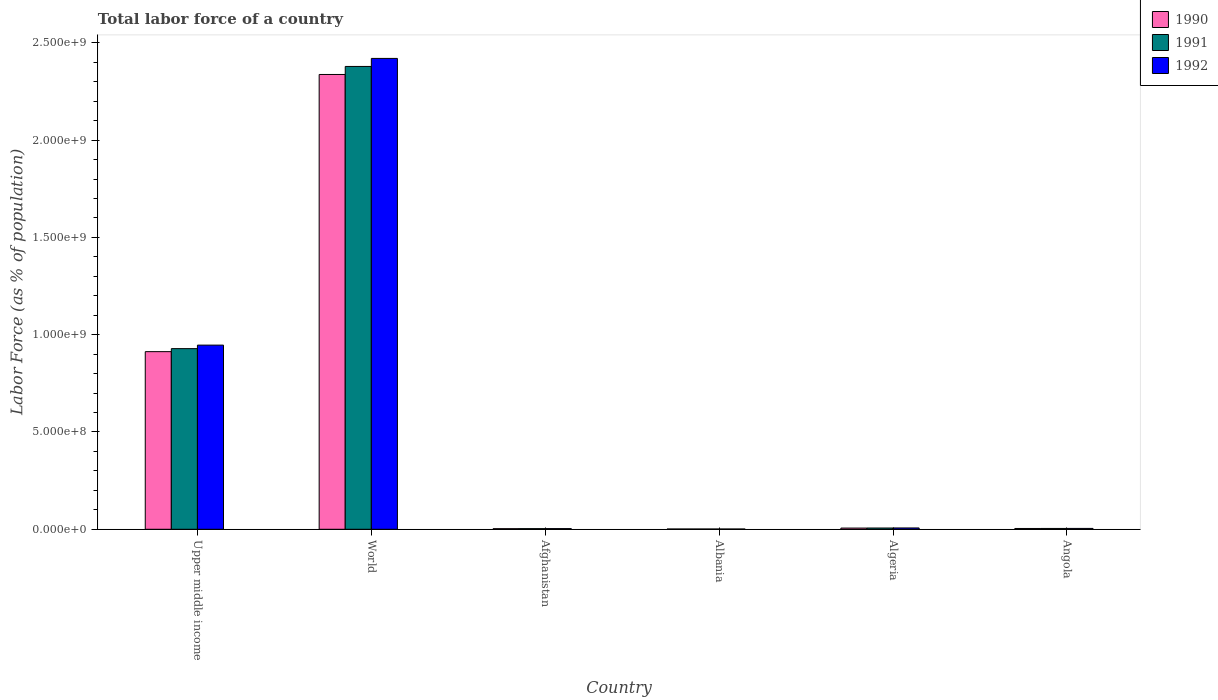How many groups of bars are there?
Keep it short and to the point. 6. Are the number of bars on each tick of the X-axis equal?
Provide a succinct answer. Yes. How many bars are there on the 2nd tick from the left?
Your answer should be compact. 3. How many bars are there on the 3rd tick from the right?
Offer a very short reply. 3. What is the label of the 4th group of bars from the left?
Keep it short and to the point. Albania. In how many cases, is the number of bars for a given country not equal to the number of legend labels?
Keep it short and to the point. 0. What is the percentage of labor force in 1991 in Upper middle income?
Your answer should be compact. 9.28e+08. Across all countries, what is the maximum percentage of labor force in 1991?
Ensure brevity in your answer.  2.38e+09. Across all countries, what is the minimum percentage of labor force in 1991?
Your answer should be very brief. 1.43e+06. In which country was the percentage of labor force in 1992 maximum?
Provide a short and direct response. World. In which country was the percentage of labor force in 1990 minimum?
Provide a succinct answer. Albania. What is the total percentage of labor force in 1990 in the graph?
Offer a very short reply. 3.27e+09. What is the difference between the percentage of labor force in 1990 in Algeria and that in Angola?
Keep it short and to the point. 2.09e+06. What is the difference between the percentage of labor force in 1990 in Algeria and the percentage of labor force in 1992 in Albania?
Your answer should be compact. 4.79e+06. What is the average percentage of labor force in 1990 per country?
Provide a succinct answer. 5.44e+08. What is the difference between the percentage of labor force of/in 1992 and percentage of labor force of/in 1991 in Angola?
Give a very brief answer. 1.55e+05. What is the ratio of the percentage of labor force in 1990 in Algeria to that in Upper middle income?
Ensure brevity in your answer.  0.01. What is the difference between the highest and the second highest percentage of labor force in 1990?
Provide a succinct answer. 1.42e+09. What is the difference between the highest and the lowest percentage of labor force in 1992?
Give a very brief answer. 2.42e+09. In how many countries, is the percentage of labor force in 1992 greater than the average percentage of labor force in 1992 taken over all countries?
Make the answer very short. 2. Are all the bars in the graph horizontal?
Your response must be concise. No. Are the values on the major ticks of Y-axis written in scientific E-notation?
Provide a short and direct response. Yes. Does the graph contain grids?
Make the answer very short. No. How many legend labels are there?
Your answer should be very brief. 3. How are the legend labels stacked?
Give a very brief answer. Vertical. What is the title of the graph?
Provide a succinct answer. Total labor force of a country. Does "1996" appear as one of the legend labels in the graph?
Your answer should be very brief. No. What is the label or title of the Y-axis?
Provide a succinct answer. Labor Force (as % of population). What is the Labor Force (as % of population) of 1990 in Upper middle income?
Offer a very short reply. 9.13e+08. What is the Labor Force (as % of population) in 1991 in Upper middle income?
Ensure brevity in your answer.  9.28e+08. What is the Labor Force (as % of population) in 1992 in Upper middle income?
Keep it short and to the point. 9.46e+08. What is the Labor Force (as % of population) in 1990 in World?
Give a very brief answer. 2.34e+09. What is the Labor Force (as % of population) in 1991 in World?
Make the answer very short. 2.38e+09. What is the Labor Force (as % of population) in 1992 in World?
Your answer should be very brief. 2.42e+09. What is the Labor Force (as % of population) of 1990 in Afghanistan?
Provide a succinct answer. 3.08e+06. What is the Labor Force (as % of population) in 1991 in Afghanistan?
Your response must be concise. 3.26e+06. What is the Labor Force (as % of population) in 1992 in Afghanistan?
Your answer should be compact. 3.50e+06. What is the Labor Force (as % of population) in 1990 in Albania?
Your answer should be very brief. 1.42e+06. What is the Labor Force (as % of population) of 1991 in Albania?
Keep it short and to the point. 1.43e+06. What is the Labor Force (as % of population) in 1992 in Albania?
Keep it short and to the point. 1.42e+06. What is the Labor Force (as % of population) of 1990 in Algeria?
Make the answer very short. 6.21e+06. What is the Labor Force (as % of population) in 1991 in Algeria?
Give a very brief answer. 6.50e+06. What is the Labor Force (as % of population) in 1992 in Algeria?
Ensure brevity in your answer.  6.81e+06. What is the Labor Force (as % of population) of 1990 in Angola?
Your answer should be very brief. 4.12e+06. What is the Labor Force (as % of population) of 1991 in Angola?
Your response must be concise. 4.24e+06. What is the Labor Force (as % of population) of 1992 in Angola?
Ensure brevity in your answer.  4.40e+06. Across all countries, what is the maximum Labor Force (as % of population) in 1990?
Your answer should be compact. 2.34e+09. Across all countries, what is the maximum Labor Force (as % of population) in 1991?
Your response must be concise. 2.38e+09. Across all countries, what is the maximum Labor Force (as % of population) of 1992?
Keep it short and to the point. 2.42e+09. Across all countries, what is the minimum Labor Force (as % of population) of 1990?
Make the answer very short. 1.42e+06. Across all countries, what is the minimum Labor Force (as % of population) in 1991?
Give a very brief answer. 1.43e+06. Across all countries, what is the minimum Labor Force (as % of population) of 1992?
Your response must be concise. 1.42e+06. What is the total Labor Force (as % of population) in 1990 in the graph?
Make the answer very short. 3.27e+09. What is the total Labor Force (as % of population) of 1991 in the graph?
Your answer should be very brief. 3.32e+09. What is the total Labor Force (as % of population) in 1992 in the graph?
Your answer should be very brief. 3.38e+09. What is the difference between the Labor Force (as % of population) of 1990 in Upper middle income and that in World?
Your response must be concise. -1.42e+09. What is the difference between the Labor Force (as % of population) in 1991 in Upper middle income and that in World?
Make the answer very short. -1.45e+09. What is the difference between the Labor Force (as % of population) of 1992 in Upper middle income and that in World?
Your answer should be very brief. -1.47e+09. What is the difference between the Labor Force (as % of population) of 1990 in Upper middle income and that in Afghanistan?
Your answer should be compact. 9.10e+08. What is the difference between the Labor Force (as % of population) of 1991 in Upper middle income and that in Afghanistan?
Your response must be concise. 9.25e+08. What is the difference between the Labor Force (as % of population) in 1992 in Upper middle income and that in Afghanistan?
Offer a terse response. 9.43e+08. What is the difference between the Labor Force (as % of population) of 1990 in Upper middle income and that in Albania?
Offer a terse response. 9.12e+08. What is the difference between the Labor Force (as % of population) of 1991 in Upper middle income and that in Albania?
Provide a short and direct response. 9.27e+08. What is the difference between the Labor Force (as % of population) in 1992 in Upper middle income and that in Albania?
Offer a very short reply. 9.45e+08. What is the difference between the Labor Force (as % of population) in 1990 in Upper middle income and that in Algeria?
Keep it short and to the point. 9.07e+08. What is the difference between the Labor Force (as % of population) in 1991 in Upper middle income and that in Algeria?
Your answer should be very brief. 9.22e+08. What is the difference between the Labor Force (as % of population) of 1992 in Upper middle income and that in Algeria?
Keep it short and to the point. 9.40e+08. What is the difference between the Labor Force (as % of population) in 1990 in Upper middle income and that in Angola?
Keep it short and to the point. 9.09e+08. What is the difference between the Labor Force (as % of population) in 1991 in Upper middle income and that in Angola?
Your response must be concise. 9.24e+08. What is the difference between the Labor Force (as % of population) of 1992 in Upper middle income and that in Angola?
Provide a short and direct response. 9.42e+08. What is the difference between the Labor Force (as % of population) in 1990 in World and that in Afghanistan?
Ensure brevity in your answer.  2.33e+09. What is the difference between the Labor Force (as % of population) of 1991 in World and that in Afghanistan?
Make the answer very short. 2.38e+09. What is the difference between the Labor Force (as % of population) of 1992 in World and that in Afghanistan?
Your answer should be very brief. 2.42e+09. What is the difference between the Labor Force (as % of population) of 1990 in World and that in Albania?
Provide a short and direct response. 2.34e+09. What is the difference between the Labor Force (as % of population) of 1991 in World and that in Albania?
Offer a very short reply. 2.38e+09. What is the difference between the Labor Force (as % of population) in 1992 in World and that in Albania?
Offer a very short reply. 2.42e+09. What is the difference between the Labor Force (as % of population) in 1990 in World and that in Algeria?
Give a very brief answer. 2.33e+09. What is the difference between the Labor Force (as % of population) in 1991 in World and that in Algeria?
Provide a succinct answer. 2.37e+09. What is the difference between the Labor Force (as % of population) of 1992 in World and that in Algeria?
Ensure brevity in your answer.  2.41e+09. What is the difference between the Labor Force (as % of population) of 1990 in World and that in Angola?
Offer a very short reply. 2.33e+09. What is the difference between the Labor Force (as % of population) of 1991 in World and that in Angola?
Provide a short and direct response. 2.37e+09. What is the difference between the Labor Force (as % of population) in 1992 in World and that in Angola?
Offer a very short reply. 2.42e+09. What is the difference between the Labor Force (as % of population) of 1990 in Afghanistan and that in Albania?
Make the answer very short. 1.66e+06. What is the difference between the Labor Force (as % of population) of 1991 in Afghanistan and that in Albania?
Provide a succinct answer. 1.84e+06. What is the difference between the Labor Force (as % of population) in 1992 in Afghanistan and that in Albania?
Keep it short and to the point. 2.08e+06. What is the difference between the Labor Force (as % of population) of 1990 in Afghanistan and that in Algeria?
Keep it short and to the point. -3.13e+06. What is the difference between the Labor Force (as % of population) in 1991 in Afghanistan and that in Algeria?
Your response must be concise. -3.24e+06. What is the difference between the Labor Force (as % of population) in 1992 in Afghanistan and that in Algeria?
Your answer should be very brief. -3.31e+06. What is the difference between the Labor Force (as % of population) of 1990 in Afghanistan and that in Angola?
Offer a very short reply. -1.03e+06. What is the difference between the Labor Force (as % of population) of 1991 in Afghanistan and that in Angola?
Offer a very short reply. -9.77e+05. What is the difference between the Labor Force (as % of population) of 1992 in Afghanistan and that in Angola?
Your answer should be compact. -8.99e+05. What is the difference between the Labor Force (as % of population) in 1990 in Albania and that in Algeria?
Offer a terse response. -4.79e+06. What is the difference between the Labor Force (as % of population) of 1991 in Albania and that in Algeria?
Ensure brevity in your answer.  -5.08e+06. What is the difference between the Labor Force (as % of population) in 1992 in Albania and that in Algeria?
Give a very brief answer. -5.39e+06. What is the difference between the Labor Force (as % of population) in 1990 in Albania and that in Angola?
Offer a very short reply. -2.70e+06. What is the difference between the Labor Force (as % of population) of 1991 in Albania and that in Angola?
Your answer should be very brief. -2.81e+06. What is the difference between the Labor Force (as % of population) of 1992 in Albania and that in Angola?
Your response must be concise. -2.98e+06. What is the difference between the Labor Force (as % of population) in 1990 in Algeria and that in Angola?
Your answer should be compact. 2.09e+06. What is the difference between the Labor Force (as % of population) of 1991 in Algeria and that in Angola?
Offer a very short reply. 2.26e+06. What is the difference between the Labor Force (as % of population) in 1992 in Algeria and that in Angola?
Keep it short and to the point. 2.42e+06. What is the difference between the Labor Force (as % of population) of 1990 in Upper middle income and the Labor Force (as % of population) of 1991 in World?
Offer a terse response. -1.47e+09. What is the difference between the Labor Force (as % of population) in 1990 in Upper middle income and the Labor Force (as % of population) in 1992 in World?
Ensure brevity in your answer.  -1.51e+09. What is the difference between the Labor Force (as % of population) in 1991 in Upper middle income and the Labor Force (as % of population) in 1992 in World?
Provide a succinct answer. -1.49e+09. What is the difference between the Labor Force (as % of population) of 1990 in Upper middle income and the Labor Force (as % of population) of 1991 in Afghanistan?
Make the answer very short. 9.10e+08. What is the difference between the Labor Force (as % of population) in 1990 in Upper middle income and the Labor Force (as % of population) in 1992 in Afghanistan?
Make the answer very short. 9.09e+08. What is the difference between the Labor Force (as % of population) of 1991 in Upper middle income and the Labor Force (as % of population) of 1992 in Afghanistan?
Provide a succinct answer. 9.25e+08. What is the difference between the Labor Force (as % of population) in 1990 in Upper middle income and the Labor Force (as % of population) in 1991 in Albania?
Make the answer very short. 9.12e+08. What is the difference between the Labor Force (as % of population) in 1990 in Upper middle income and the Labor Force (as % of population) in 1992 in Albania?
Offer a terse response. 9.12e+08. What is the difference between the Labor Force (as % of population) of 1991 in Upper middle income and the Labor Force (as % of population) of 1992 in Albania?
Make the answer very short. 9.27e+08. What is the difference between the Labor Force (as % of population) of 1990 in Upper middle income and the Labor Force (as % of population) of 1991 in Algeria?
Make the answer very short. 9.06e+08. What is the difference between the Labor Force (as % of population) in 1990 in Upper middle income and the Labor Force (as % of population) in 1992 in Algeria?
Offer a very short reply. 9.06e+08. What is the difference between the Labor Force (as % of population) of 1991 in Upper middle income and the Labor Force (as % of population) of 1992 in Algeria?
Provide a succinct answer. 9.22e+08. What is the difference between the Labor Force (as % of population) in 1990 in Upper middle income and the Labor Force (as % of population) in 1991 in Angola?
Your answer should be very brief. 9.09e+08. What is the difference between the Labor Force (as % of population) in 1990 in Upper middle income and the Labor Force (as % of population) in 1992 in Angola?
Make the answer very short. 9.09e+08. What is the difference between the Labor Force (as % of population) of 1991 in Upper middle income and the Labor Force (as % of population) of 1992 in Angola?
Keep it short and to the point. 9.24e+08. What is the difference between the Labor Force (as % of population) in 1990 in World and the Labor Force (as % of population) in 1991 in Afghanistan?
Give a very brief answer. 2.33e+09. What is the difference between the Labor Force (as % of population) in 1990 in World and the Labor Force (as % of population) in 1992 in Afghanistan?
Provide a short and direct response. 2.33e+09. What is the difference between the Labor Force (as % of population) in 1991 in World and the Labor Force (as % of population) in 1992 in Afghanistan?
Provide a succinct answer. 2.38e+09. What is the difference between the Labor Force (as % of population) in 1990 in World and the Labor Force (as % of population) in 1991 in Albania?
Offer a very short reply. 2.34e+09. What is the difference between the Labor Force (as % of population) in 1990 in World and the Labor Force (as % of population) in 1992 in Albania?
Ensure brevity in your answer.  2.34e+09. What is the difference between the Labor Force (as % of population) of 1991 in World and the Labor Force (as % of population) of 1992 in Albania?
Your response must be concise. 2.38e+09. What is the difference between the Labor Force (as % of population) in 1990 in World and the Labor Force (as % of population) in 1991 in Algeria?
Keep it short and to the point. 2.33e+09. What is the difference between the Labor Force (as % of population) of 1990 in World and the Labor Force (as % of population) of 1992 in Algeria?
Provide a succinct answer. 2.33e+09. What is the difference between the Labor Force (as % of population) of 1991 in World and the Labor Force (as % of population) of 1992 in Algeria?
Offer a very short reply. 2.37e+09. What is the difference between the Labor Force (as % of population) in 1990 in World and the Labor Force (as % of population) in 1991 in Angola?
Your response must be concise. 2.33e+09. What is the difference between the Labor Force (as % of population) in 1990 in World and the Labor Force (as % of population) in 1992 in Angola?
Offer a very short reply. 2.33e+09. What is the difference between the Labor Force (as % of population) of 1991 in World and the Labor Force (as % of population) of 1992 in Angola?
Offer a terse response. 2.37e+09. What is the difference between the Labor Force (as % of population) in 1990 in Afghanistan and the Labor Force (as % of population) in 1991 in Albania?
Your response must be concise. 1.66e+06. What is the difference between the Labor Force (as % of population) of 1990 in Afghanistan and the Labor Force (as % of population) of 1992 in Albania?
Offer a very short reply. 1.67e+06. What is the difference between the Labor Force (as % of population) in 1991 in Afghanistan and the Labor Force (as % of population) in 1992 in Albania?
Keep it short and to the point. 1.85e+06. What is the difference between the Labor Force (as % of population) in 1990 in Afghanistan and the Labor Force (as % of population) in 1991 in Algeria?
Offer a terse response. -3.42e+06. What is the difference between the Labor Force (as % of population) in 1990 in Afghanistan and the Labor Force (as % of population) in 1992 in Algeria?
Provide a short and direct response. -3.73e+06. What is the difference between the Labor Force (as % of population) in 1991 in Afghanistan and the Labor Force (as % of population) in 1992 in Algeria?
Provide a short and direct response. -3.55e+06. What is the difference between the Labor Force (as % of population) of 1990 in Afghanistan and the Labor Force (as % of population) of 1991 in Angola?
Offer a terse response. -1.16e+06. What is the difference between the Labor Force (as % of population) of 1990 in Afghanistan and the Labor Force (as % of population) of 1992 in Angola?
Your answer should be very brief. -1.31e+06. What is the difference between the Labor Force (as % of population) of 1991 in Afghanistan and the Labor Force (as % of population) of 1992 in Angola?
Your answer should be very brief. -1.13e+06. What is the difference between the Labor Force (as % of population) of 1990 in Albania and the Labor Force (as % of population) of 1991 in Algeria?
Provide a short and direct response. -5.08e+06. What is the difference between the Labor Force (as % of population) in 1990 in Albania and the Labor Force (as % of population) in 1992 in Algeria?
Provide a succinct answer. -5.39e+06. What is the difference between the Labor Force (as % of population) in 1991 in Albania and the Labor Force (as % of population) in 1992 in Algeria?
Give a very brief answer. -5.38e+06. What is the difference between the Labor Force (as % of population) of 1990 in Albania and the Labor Force (as % of population) of 1991 in Angola?
Ensure brevity in your answer.  -2.82e+06. What is the difference between the Labor Force (as % of population) in 1990 in Albania and the Labor Force (as % of population) in 1992 in Angola?
Your answer should be very brief. -2.98e+06. What is the difference between the Labor Force (as % of population) of 1991 in Albania and the Labor Force (as % of population) of 1992 in Angola?
Make the answer very short. -2.97e+06. What is the difference between the Labor Force (as % of population) of 1990 in Algeria and the Labor Force (as % of population) of 1991 in Angola?
Ensure brevity in your answer.  1.97e+06. What is the difference between the Labor Force (as % of population) of 1990 in Algeria and the Labor Force (as % of population) of 1992 in Angola?
Your response must be concise. 1.82e+06. What is the difference between the Labor Force (as % of population) in 1991 in Algeria and the Labor Force (as % of population) in 1992 in Angola?
Offer a very short reply. 2.11e+06. What is the average Labor Force (as % of population) in 1990 per country?
Give a very brief answer. 5.44e+08. What is the average Labor Force (as % of population) of 1991 per country?
Ensure brevity in your answer.  5.54e+08. What is the average Labor Force (as % of population) in 1992 per country?
Give a very brief answer. 5.64e+08. What is the difference between the Labor Force (as % of population) in 1990 and Labor Force (as % of population) in 1991 in Upper middle income?
Ensure brevity in your answer.  -1.55e+07. What is the difference between the Labor Force (as % of population) of 1990 and Labor Force (as % of population) of 1992 in Upper middle income?
Provide a short and direct response. -3.35e+07. What is the difference between the Labor Force (as % of population) in 1991 and Labor Force (as % of population) in 1992 in Upper middle income?
Give a very brief answer. -1.81e+07. What is the difference between the Labor Force (as % of population) of 1990 and Labor Force (as % of population) of 1991 in World?
Keep it short and to the point. -4.13e+07. What is the difference between the Labor Force (as % of population) in 1990 and Labor Force (as % of population) in 1992 in World?
Ensure brevity in your answer.  -8.26e+07. What is the difference between the Labor Force (as % of population) of 1991 and Labor Force (as % of population) of 1992 in World?
Provide a succinct answer. -4.13e+07. What is the difference between the Labor Force (as % of population) of 1990 and Labor Force (as % of population) of 1991 in Afghanistan?
Ensure brevity in your answer.  -1.80e+05. What is the difference between the Labor Force (as % of population) of 1990 and Labor Force (as % of population) of 1992 in Afghanistan?
Make the answer very short. -4.13e+05. What is the difference between the Labor Force (as % of population) of 1991 and Labor Force (as % of population) of 1992 in Afghanistan?
Offer a terse response. -2.33e+05. What is the difference between the Labor Force (as % of population) in 1990 and Labor Force (as % of population) in 1991 in Albania?
Keep it short and to the point. -6581. What is the difference between the Labor Force (as % of population) in 1990 and Labor Force (as % of population) in 1992 in Albania?
Offer a very short reply. 2941. What is the difference between the Labor Force (as % of population) of 1991 and Labor Force (as % of population) of 1992 in Albania?
Make the answer very short. 9522. What is the difference between the Labor Force (as % of population) of 1990 and Labor Force (as % of population) of 1991 in Algeria?
Give a very brief answer. -2.94e+05. What is the difference between the Labor Force (as % of population) of 1990 and Labor Force (as % of population) of 1992 in Algeria?
Offer a very short reply. -6.01e+05. What is the difference between the Labor Force (as % of population) of 1991 and Labor Force (as % of population) of 1992 in Algeria?
Provide a short and direct response. -3.07e+05. What is the difference between the Labor Force (as % of population) in 1990 and Labor Force (as % of population) in 1991 in Angola?
Provide a short and direct response. -1.22e+05. What is the difference between the Labor Force (as % of population) in 1990 and Labor Force (as % of population) in 1992 in Angola?
Give a very brief answer. -2.77e+05. What is the difference between the Labor Force (as % of population) of 1991 and Labor Force (as % of population) of 1992 in Angola?
Ensure brevity in your answer.  -1.55e+05. What is the ratio of the Labor Force (as % of population) of 1990 in Upper middle income to that in World?
Provide a short and direct response. 0.39. What is the ratio of the Labor Force (as % of population) of 1991 in Upper middle income to that in World?
Give a very brief answer. 0.39. What is the ratio of the Labor Force (as % of population) of 1992 in Upper middle income to that in World?
Your answer should be compact. 0.39. What is the ratio of the Labor Force (as % of population) in 1990 in Upper middle income to that in Afghanistan?
Ensure brevity in your answer.  296.08. What is the ratio of the Labor Force (as % of population) of 1991 in Upper middle income to that in Afghanistan?
Offer a terse response. 284.49. What is the ratio of the Labor Force (as % of population) in 1992 in Upper middle income to that in Afghanistan?
Make the answer very short. 270.69. What is the ratio of the Labor Force (as % of population) in 1990 in Upper middle income to that in Albania?
Offer a very short reply. 642.88. What is the ratio of the Labor Force (as % of population) in 1991 in Upper middle income to that in Albania?
Give a very brief answer. 650.78. What is the ratio of the Labor Force (as % of population) in 1992 in Upper middle income to that in Albania?
Your answer should be compact. 667.89. What is the ratio of the Labor Force (as % of population) of 1990 in Upper middle income to that in Algeria?
Make the answer very short. 147. What is the ratio of the Labor Force (as % of population) in 1991 in Upper middle income to that in Algeria?
Offer a terse response. 142.74. What is the ratio of the Labor Force (as % of population) of 1992 in Upper middle income to that in Algeria?
Offer a terse response. 138.96. What is the ratio of the Labor Force (as % of population) of 1990 in Upper middle income to that in Angola?
Ensure brevity in your answer.  221.68. What is the ratio of the Labor Force (as % of population) in 1991 in Upper middle income to that in Angola?
Offer a terse response. 218.94. What is the ratio of the Labor Force (as % of population) in 1992 in Upper middle income to that in Angola?
Your response must be concise. 215.35. What is the ratio of the Labor Force (as % of population) in 1990 in World to that in Afghanistan?
Your response must be concise. 758.09. What is the ratio of the Labor Force (as % of population) in 1991 in World to that in Afghanistan?
Provide a short and direct response. 728.92. What is the ratio of the Labor Force (as % of population) of 1992 in World to that in Afghanistan?
Offer a very short reply. 692.14. What is the ratio of the Labor Force (as % of population) of 1990 in World to that in Albania?
Your answer should be compact. 1646.06. What is the ratio of the Labor Force (as % of population) of 1991 in World to that in Albania?
Give a very brief answer. 1667.42. What is the ratio of the Labor Force (as % of population) of 1992 in World to that in Albania?
Provide a succinct answer. 1707.73. What is the ratio of the Labor Force (as % of population) in 1990 in World to that in Algeria?
Your answer should be compact. 376.37. What is the ratio of the Labor Force (as % of population) in 1991 in World to that in Algeria?
Your response must be concise. 365.71. What is the ratio of the Labor Force (as % of population) of 1992 in World to that in Algeria?
Your response must be concise. 355.31. What is the ratio of the Labor Force (as % of population) in 1990 in World to that in Angola?
Give a very brief answer. 567.6. What is the ratio of the Labor Force (as % of population) of 1991 in World to that in Angola?
Provide a succinct answer. 560.97. What is the ratio of the Labor Force (as % of population) of 1992 in World to that in Angola?
Ensure brevity in your answer.  550.64. What is the ratio of the Labor Force (as % of population) of 1990 in Afghanistan to that in Albania?
Offer a terse response. 2.17. What is the ratio of the Labor Force (as % of population) in 1991 in Afghanistan to that in Albania?
Provide a short and direct response. 2.29. What is the ratio of the Labor Force (as % of population) of 1992 in Afghanistan to that in Albania?
Give a very brief answer. 2.47. What is the ratio of the Labor Force (as % of population) in 1990 in Afghanistan to that in Algeria?
Provide a short and direct response. 0.5. What is the ratio of the Labor Force (as % of population) in 1991 in Afghanistan to that in Algeria?
Ensure brevity in your answer.  0.5. What is the ratio of the Labor Force (as % of population) of 1992 in Afghanistan to that in Algeria?
Ensure brevity in your answer.  0.51. What is the ratio of the Labor Force (as % of population) in 1990 in Afghanistan to that in Angola?
Make the answer very short. 0.75. What is the ratio of the Labor Force (as % of population) in 1991 in Afghanistan to that in Angola?
Provide a short and direct response. 0.77. What is the ratio of the Labor Force (as % of population) of 1992 in Afghanistan to that in Angola?
Offer a terse response. 0.8. What is the ratio of the Labor Force (as % of population) in 1990 in Albania to that in Algeria?
Your response must be concise. 0.23. What is the ratio of the Labor Force (as % of population) in 1991 in Albania to that in Algeria?
Offer a terse response. 0.22. What is the ratio of the Labor Force (as % of population) in 1992 in Albania to that in Algeria?
Your answer should be compact. 0.21. What is the ratio of the Labor Force (as % of population) in 1990 in Albania to that in Angola?
Your answer should be very brief. 0.34. What is the ratio of the Labor Force (as % of population) of 1991 in Albania to that in Angola?
Ensure brevity in your answer.  0.34. What is the ratio of the Labor Force (as % of population) of 1992 in Albania to that in Angola?
Your response must be concise. 0.32. What is the ratio of the Labor Force (as % of population) of 1990 in Algeria to that in Angola?
Your response must be concise. 1.51. What is the ratio of the Labor Force (as % of population) of 1991 in Algeria to that in Angola?
Keep it short and to the point. 1.53. What is the ratio of the Labor Force (as % of population) of 1992 in Algeria to that in Angola?
Your answer should be compact. 1.55. What is the difference between the highest and the second highest Labor Force (as % of population) in 1990?
Your answer should be very brief. 1.42e+09. What is the difference between the highest and the second highest Labor Force (as % of population) of 1991?
Ensure brevity in your answer.  1.45e+09. What is the difference between the highest and the second highest Labor Force (as % of population) of 1992?
Give a very brief answer. 1.47e+09. What is the difference between the highest and the lowest Labor Force (as % of population) of 1990?
Give a very brief answer. 2.34e+09. What is the difference between the highest and the lowest Labor Force (as % of population) of 1991?
Keep it short and to the point. 2.38e+09. What is the difference between the highest and the lowest Labor Force (as % of population) of 1992?
Give a very brief answer. 2.42e+09. 